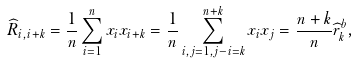Convert formula to latex. <formula><loc_0><loc_0><loc_500><loc_500>\widehat { R } _ { i , i + k } = \frac { 1 } { n } \sum _ { i = 1 } ^ { n } x _ { i } x _ { i + k } = \frac { 1 } { n } \sum _ { i , j = 1 , j - i = k } ^ { n + k } x _ { i } x _ { j } = \frac { n + k } { n } \widehat { r } ^ { b } _ { k } ,</formula> 